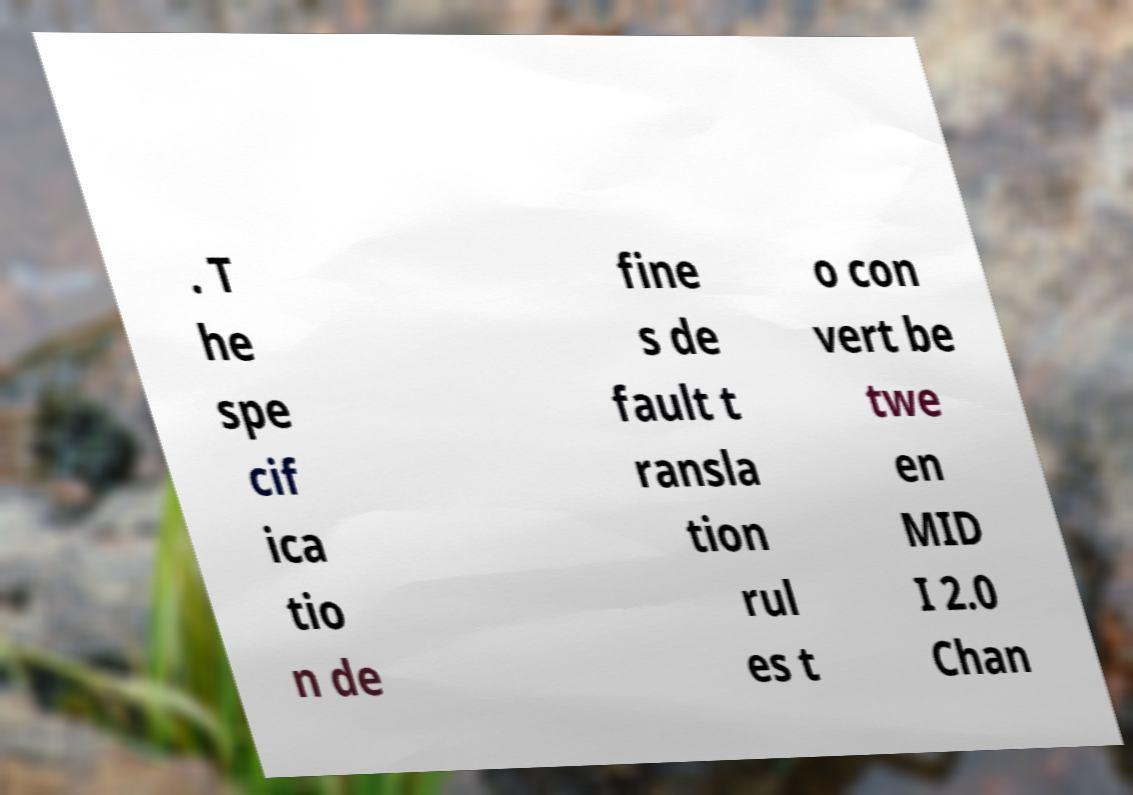There's text embedded in this image that I need extracted. Can you transcribe it verbatim? . T he spe cif ica tio n de fine s de fault t ransla tion rul es t o con vert be twe en MID I 2.0 Chan 